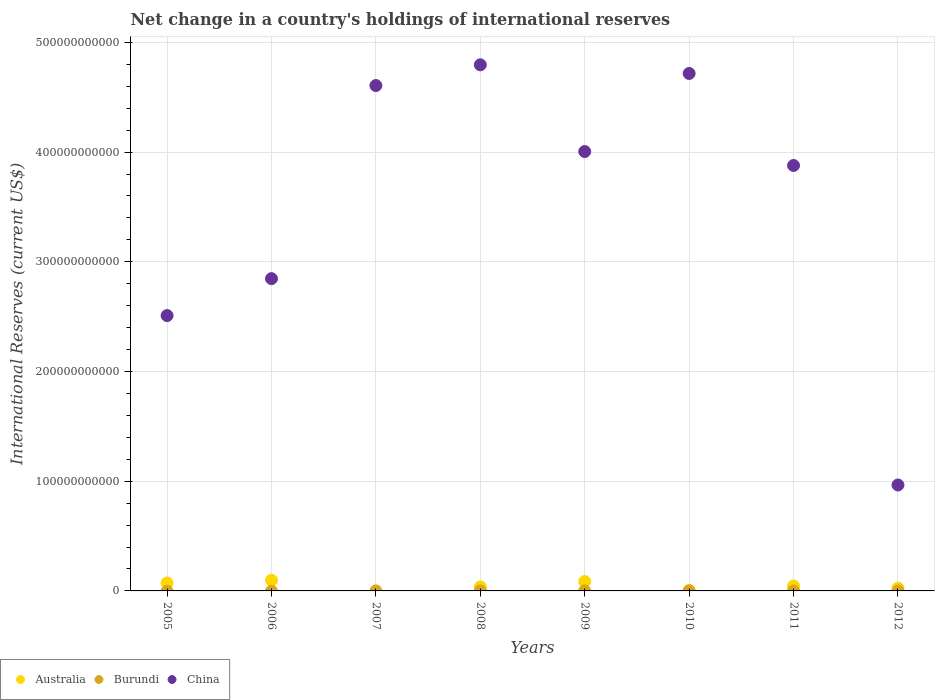How many different coloured dotlines are there?
Keep it short and to the point. 3. Across all years, what is the maximum international reserves in Australia?
Ensure brevity in your answer.  9.72e+09. Across all years, what is the minimum international reserves in Burundi?
Provide a short and direct response. 0. What is the total international reserves in Burundi in the graph?
Make the answer very short. 2.48e+08. What is the difference between the international reserves in Australia in 2006 and that in 2008?
Offer a terse response. 6.03e+09. What is the difference between the international reserves in Burundi in 2006 and the international reserves in China in 2009?
Keep it short and to the point. -4.01e+11. What is the average international reserves in China per year?
Offer a very short reply. 3.54e+11. In the year 2012, what is the difference between the international reserves in Burundi and international reserves in China?
Provide a succinct answer. -9.65e+1. What is the ratio of the international reserves in Australia in 2008 to that in 2009?
Give a very brief answer. 0.43. Is the international reserves in China in 2005 less than that in 2011?
Make the answer very short. Yes. What is the difference between the highest and the second highest international reserves in Australia?
Ensure brevity in your answer.  1.17e+09. What is the difference between the highest and the lowest international reserves in China?
Offer a terse response. 3.83e+11. In how many years, is the international reserves in Burundi greater than the average international reserves in Burundi taken over all years?
Offer a terse response. 3. Is it the case that in every year, the sum of the international reserves in Burundi and international reserves in China  is greater than the international reserves in Australia?
Offer a terse response. Yes. Is the international reserves in Burundi strictly greater than the international reserves in Australia over the years?
Offer a terse response. No. How many years are there in the graph?
Provide a succinct answer. 8. What is the difference between two consecutive major ticks on the Y-axis?
Your response must be concise. 1.00e+11. Are the values on the major ticks of Y-axis written in scientific E-notation?
Keep it short and to the point. No. Does the graph contain grids?
Offer a very short reply. Yes. How are the legend labels stacked?
Offer a terse response. Horizontal. What is the title of the graph?
Give a very brief answer. Net change in a country's holdings of international reserves. What is the label or title of the X-axis?
Provide a short and direct response. Years. What is the label or title of the Y-axis?
Ensure brevity in your answer.  International Reserves (current US$). What is the International Reserves (current US$) in Australia in 2005?
Make the answer very short. 7.25e+09. What is the International Reserves (current US$) in China in 2005?
Offer a terse response. 2.51e+11. What is the International Reserves (current US$) in Australia in 2006?
Provide a short and direct response. 9.72e+09. What is the International Reserves (current US$) in China in 2006?
Make the answer very short. 2.85e+11. What is the International Reserves (current US$) of Burundi in 2007?
Provide a short and direct response. 5.10e+07. What is the International Reserves (current US$) in China in 2007?
Ensure brevity in your answer.  4.61e+11. What is the International Reserves (current US$) of Australia in 2008?
Your answer should be very brief. 3.69e+09. What is the International Reserves (current US$) in Burundi in 2008?
Ensure brevity in your answer.  8.81e+07. What is the International Reserves (current US$) in China in 2008?
Your response must be concise. 4.80e+11. What is the International Reserves (current US$) of Australia in 2009?
Ensure brevity in your answer.  8.55e+09. What is the International Reserves (current US$) in Burundi in 2009?
Your answer should be very brief. 8.16e+07. What is the International Reserves (current US$) in China in 2009?
Offer a terse response. 4.01e+11. What is the International Reserves (current US$) in Australia in 2010?
Keep it short and to the point. 4.30e+08. What is the International Reserves (current US$) of China in 2010?
Your answer should be very brief. 4.72e+11. What is the International Reserves (current US$) in Australia in 2011?
Offer a terse response. 4.55e+09. What is the International Reserves (current US$) of Burundi in 2011?
Ensure brevity in your answer.  0. What is the International Reserves (current US$) of China in 2011?
Offer a terse response. 3.88e+11. What is the International Reserves (current US$) in Australia in 2012?
Offer a terse response. 2.54e+09. What is the International Reserves (current US$) in Burundi in 2012?
Your response must be concise. 2.76e+07. What is the International Reserves (current US$) of China in 2012?
Ensure brevity in your answer.  9.66e+1. Across all years, what is the maximum International Reserves (current US$) in Australia?
Offer a terse response. 9.72e+09. Across all years, what is the maximum International Reserves (current US$) of Burundi?
Offer a terse response. 8.81e+07. Across all years, what is the maximum International Reserves (current US$) in China?
Your answer should be very brief. 4.80e+11. Across all years, what is the minimum International Reserves (current US$) of Australia?
Ensure brevity in your answer.  0. Across all years, what is the minimum International Reserves (current US$) in Burundi?
Your answer should be compact. 0. Across all years, what is the minimum International Reserves (current US$) in China?
Give a very brief answer. 9.66e+1. What is the total International Reserves (current US$) in Australia in the graph?
Your answer should be very brief. 3.67e+1. What is the total International Reserves (current US$) of Burundi in the graph?
Give a very brief answer. 2.48e+08. What is the total International Reserves (current US$) of China in the graph?
Provide a succinct answer. 2.83e+12. What is the difference between the International Reserves (current US$) of Australia in 2005 and that in 2006?
Offer a terse response. -2.47e+09. What is the difference between the International Reserves (current US$) in China in 2005 and that in 2006?
Provide a succinct answer. -3.37e+1. What is the difference between the International Reserves (current US$) in China in 2005 and that in 2007?
Provide a succinct answer. -2.10e+11. What is the difference between the International Reserves (current US$) in Australia in 2005 and that in 2008?
Give a very brief answer. 3.56e+09. What is the difference between the International Reserves (current US$) in China in 2005 and that in 2008?
Offer a terse response. -2.29e+11. What is the difference between the International Reserves (current US$) of Australia in 2005 and that in 2009?
Make the answer very short. -1.29e+09. What is the difference between the International Reserves (current US$) in China in 2005 and that in 2009?
Give a very brief answer. -1.50e+11. What is the difference between the International Reserves (current US$) in Australia in 2005 and that in 2010?
Provide a succinct answer. 6.82e+09. What is the difference between the International Reserves (current US$) of China in 2005 and that in 2010?
Your response must be concise. -2.21e+11. What is the difference between the International Reserves (current US$) in Australia in 2005 and that in 2011?
Your response must be concise. 2.71e+09. What is the difference between the International Reserves (current US$) of China in 2005 and that in 2011?
Offer a very short reply. -1.37e+11. What is the difference between the International Reserves (current US$) in Australia in 2005 and that in 2012?
Provide a succinct answer. 4.72e+09. What is the difference between the International Reserves (current US$) in China in 2005 and that in 2012?
Provide a succinct answer. 1.54e+11. What is the difference between the International Reserves (current US$) of China in 2006 and that in 2007?
Your answer should be compact. -1.76e+11. What is the difference between the International Reserves (current US$) of Australia in 2006 and that in 2008?
Ensure brevity in your answer.  6.03e+09. What is the difference between the International Reserves (current US$) in China in 2006 and that in 2008?
Your answer should be compact. -1.95e+11. What is the difference between the International Reserves (current US$) of Australia in 2006 and that in 2009?
Offer a very short reply. 1.17e+09. What is the difference between the International Reserves (current US$) of China in 2006 and that in 2009?
Your answer should be very brief. -1.16e+11. What is the difference between the International Reserves (current US$) of Australia in 2006 and that in 2010?
Offer a terse response. 9.29e+09. What is the difference between the International Reserves (current US$) in China in 2006 and that in 2010?
Your answer should be compact. -1.87e+11. What is the difference between the International Reserves (current US$) in Australia in 2006 and that in 2011?
Your response must be concise. 5.18e+09. What is the difference between the International Reserves (current US$) of China in 2006 and that in 2011?
Your response must be concise. -1.03e+11. What is the difference between the International Reserves (current US$) in Australia in 2006 and that in 2012?
Ensure brevity in your answer.  7.19e+09. What is the difference between the International Reserves (current US$) in China in 2006 and that in 2012?
Ensure brevity in your answer.  1.88e+11. What is the difference between the International Reserves (current US$) of Burundi in 2007 and that in 2008?
Offer a terse response. -3.71e+07. What is the difference between the International Reserves (current US$) of China in 2007 and that in 2008?
Offer a terse response. -1.89e+1. What is the difference between the International Reserves (current US$) of Burundi in 2007 and that in 2009?
Offer a terse response. -3.06e+07. What is the difference between the International Reserves (current US$) of China in 2007 and that in 2009?
Your answer should be very brief. 6.01e+1. What is the difference between the International Reserves (current US$) of China in 2007 and that in 2010?
Your answer should be compact. -1.10e+1. What is the difference between the International Reserves (current US$) in China in 2007 and that in 2011?
Keep it short and to the point. 7.29e+1. What is the difference between the International Reserves (current US$) of Burundi in 2007 and that in 2012?
Your answer should be very brief. 2.33e+07. What is the difference between the International Reserves (current US$) in China in 2007 and that in 2012?
Your response must be concise. 3.64e+11. What is the difference between the International Reserves (current US$) of Australia in 2008 and that in 2009?
Make the answer very short. -4.86e+09. What is the difference between the International Reserves (current US$) of Burundi in 2008 and that in 2009?
Ensure brevity in your answer.  6.47e+06. What is the difference between the International Reserves (current US$) of China in 2008 and that in 2009?
Keep it short and to the point. 7.90e+1. What is the difference between the International Reserves (current US$) of Australia in 2008 and that in 2010?
Give a very brief answer. 3.26e+09. What is the difference between the International Reserves (current US$) of China in 2008 and that in 2010?
Offer a very short reply. 7.89e+09. What is the difference between the International Reserves (current US$) of Australia in 2008 and that in 2011?
Ensure brevity in your answer.  -8.55e+08. What is the difference between the International Reserves (current US$) in China in 2008 and that in 2011?
Your answer should be very brief. 9.18e+1. What is the difference between the International Reserves (current US$) of Australia in 2008 and that in 2012?
Offer a terse response. 1.16e+09. What is the difference between the International Reserves (current US$) of Burundi in 2008 and that in 2012?
Keep it short and to the point. 6.04e+07. What is the difference between the International Reserves (current US$) in China in 2008 and that in 2012?
Your answer should be compact. 3.83e+11. What is the difference between the International Reserves (current US$) in Australia in 2009 and that in 2010?
Your response must be concise. 8.12e+09. What is the difference between the International Reserves (current US$) of China in 2009 and that in 2010?
Ensure brevity in your answer.  -7.12e+1. What is the difference between the International Reserves (current US$) in Australia in 2009 and that in 2011?
Offer a very short reply. 4.00e+09. What is the difference between the International Reserves (current US$) of China in 2009 and that in 2011?
Keep it short and to the point. 1.27e+1. What is the difference between the International Reserves (current US$) of Australia in 2009 and that in 2012?
Your answer should be very brief. 6.01e+09. What is the difference between the International Reserves (current US$) of Burundi in 2009 and that in 2012?
Provide a short and direct response. 5.39e+07. What is the difference between the International Reserves (current US$) in China in 2009 and that in 2012?
Make the answer very short. 3.04e+11. What is the difference between the International Reserves (current US$) in Australia in 2010 and that in 2011?
Offer a terse response. -4.12e+09. What is the difference between the International Reserves (current US$) in China in 2010 and that in 2011?
Provide a succinct answer. 8.39e+1. What is the difference between the International Reserves (current US$) of Australia in 2010 and that in 2012?
Your response must be concise. -2.11e+09. What is the difference between the International Reserves (current US$) in China in 2010 and that in 2012?
Provide a short and direct response. 3.75e+11. What is the difference between the International Reserves (current US$) in Australia in 2011 and that in 2012?
Provide a succinct answer. 2.01e+09. What is the difference between the International Reserves (current US$) in China in 2011 and that in 2012?
Keep it short and to the point. 2.91e+11. What is the difference between the International Reserves (current US$) in Australia in 2005 and the International Reserves (current US$) in China in 2006?
Make the answer very short. -2.77e+11. What is the difference between the International Reserves (current US$) in Australia in 2005 and the International Reserves (current US$) in Burundi in 2007?
Give a very brief answer. 7.20e+09. What is the difference between the International Reserves (current US$) of Australia in 2005 and the International Reserves (current US$) of China in 2007?
Keep it short and to the point. -4.53e+11. What is the difference between the International Reserves (current US$) in Australia in 2005 and the International Reserves (current US$) in Burundi in 2008?
Keep it short and to the point. 7.17e+09. What is the difference between the International Reserves (current US$) of Australia in 2005 and the International Reserves (current US$) of China in 2008?
Your answer should be compact. -4.72e+11. What is the difference between the International Reserves (current US$) of Australia in 2005 and the International Reserves (current US$) of Burundi in 2009?
Provide a short and direct response. 7.17e+09. What is the difference between the International Reserves (current US$) in Australia in 2005 and the International Reserves (current US$) in China in 2009?
Offer a very short reply. -3.93e+11. What is the difference between the International Reserves (current US$) of Australia in 2005 and the International Reserves (current US$) of China in 2010?
Keep it short and to the point. -4.64e+11. What is the difference between the International Reserves (current US$) of Australia in 2005 and the International Reserves (current US$) of China in 2011?
Offer a very short reply. -3.81e+11. What is the difference between the International Reserves (current US$) in Australia in 2005 and the International Reserves (current US$) in Burundi in 2012?
Your answer should be very brief. 7.23e+09. What is the difference between the International Reserves (current US$) in Australia in 2005 and the International Reserves (current US$) in China in 2012?
Your response must be concise. -8.93e+1. What is the difference between the International Reserves (current US$) in Australia in 2006 and the International Reserves (current US$) in Burundi in 2007?
Provide a short and direct response. 9.67e+09. What is the difference between the International Reserves (current US$) in Australia in 2006 and the International Reserves (current US$) in China in 2007?
Make the answer very short. -4.51e+11. What is the difference between the International Reserves (current US$) in Australia in 2006 and the International Reserves (current US$) in Burundi in 2008?
Ensure brevity in your answer.  9.63e+09. What is the difference between the International Reserves (current US$) of Australia in 2006 and the International Reserves (current US$) of China in 2008?
Your answer should be very brief. -4.70e+11. What is the difference between the International Reserves (current US$) of Australia in 2006 and the International Reserves (current US$) of Burundi in 2009?
Your answer should be compact. 9.64e+09. What is the difference between the International Reserves (current US$) of Australia in 2006 and the International Reserves (current US$) of China in 2009?
Provide a short and direct response. -3.91e+11. What is the difference between the International Reserves (current US$) of Australia in 2006 and the International Reserves (current US$) of China in 2010?
Your answer should be compact. -4.62e+11. What is the difference between the International Reserves (current US$) in Australia in 2006 and the International Reserves (current US$) in China in 2011?
Give a very brief answer. -3.78e+11. What is the difference between the International Reserves (current US$) in Australia in 2006 and the International Reserves (current US$) in Burundi in 2012?
Offer a terse response. 9.70e+09. What is the difference between the International Reserves (current US$) in Australia in 2006 and the International Reserves (current US$) in China in 2012?
Keep it short and to the point. -8.68e+1. What is the difference between the International Reserves (current US$) of Burundi in 2007 and the International Reserves (current US$) of China in 2008?
Your answer should be very brief. -4.80e+11. What is the difference between the International Reserves (current US$) in Burundi in 2007 and the International Reserves (current US$) in China in 2009?
Ensure brevity in your answer.  -4.00e+11. What is the difference between the International Reserves (current US$) in Burundi in 2007 and the International Reserves (current US$) in China in 2010?
Offer a very short reply. -4.72e+11. What is the difference between the International Reserves (current US$) in Burundi in 2007 and the International Reserves (current US$) in China in 2011?
Your answer should be compact. -3.88e+11. What is the difference between the International Reserves (current US$) in Burundi in 2007 and the International Reserves (current US$) in China in 2012?
Your answer should be compact. -9.65e+1. What is the difference between the International Reserves (current US$) in Australia in 2008 and the International Reserves (current US$) in Burundi in 2009?
Offer a terse response. 3.61e+09. What is the difference between the International Reserves (current US$) of Australia in 2008 and the International Reserves (current US$) of China in 2009?
Provide a succinct answer. -3.97e+11. What is the difference between the International Reserves (current US$) in Burundi in 2008 and the International Reserves (current US$) in China in 2009?
Keep it short and to the point. -4.00e+11. What is the difference between the International Reserves (current US$) in Australia in 2008 and the International Reserves (current US$) in China in 2010?
Provide a short and direct response. -4.68e+11. What is the difference between the International Reserves (current US$) of Burundi in 2008 and the International Reserves (current US$) of China in 2010?
Provide a short and direct response. -4.72e+11. What is the difference between the International Reserves (current US$) of Australia in 2008 and the International Reserves (current US$) of China in 2011?
Provide a short and direct response. -3.84e+11. What is the difference between the International Reserves (current US$) in Burundi in 2008 and the International Reserves (current US$) in China in 2011?
Make the answer very short. -3.88e+11. What is the difference between the International Reserves (current US$) in Australia in 2008 and the International Reserves (current US$) in Burundi in 2012?
Make the answer very short. 3.66e+09. What is the difference between the International Reserves (current US$) of Australia in 2008 and the International Reserves (current US$) of China in 2012?
Ensure brevity in your answer.  -9.29e+1. What is the difference between the International Reserves (current US$) in Burundi in 2008 and the International Reserves (current US$) in China in 2012?
Offer a very short reply. -9.65e+1. What is the difference between the International Reserves (current US$) of Australia in 2009 and the International Reserves (current US$) of China in 2010?
Your response must be concise. -4.63e+11. What is the difference between the International Reserves (current US$) in Burundi in 2009 and the International Reserves (current US$) in China in 2010?
Provide a succinct answer. -4.72e+11. What is the difference between the International Reserves (current US$) in Australia in 2009 and the International Reserves (current US$) in China in 2011?
Give a very brief answer. -3.79e+11. What is the difference between the International Reserves (current US$) of Burundi in 2009 and the International Reserves (current US$) of China in 2011?
Provide a short and direct response. -3.88e+11. What is the difference between the International Reserves (current US$) in Australia in 2009 and the International Reserves (current US$) in Burundi in 2012?
Give a very brief answer. 8.52e+09. What is the difference between the International Reserves (current US$) of Australia in 2009 and the International Reserves (current US$) of China in 2012?
Offer a very short reply. -8.80e+1. What is the difference between the International Reserves (current US$) in Burundi in 2009 and the International Reserves (current US$) in China in 2012?
Offer a very short reply. -9.65e+1. What is the difference between the International Reserves (current US$) in Australia in 2010 and the International Reserves (current US$) in China in 2011?
Keep it short and to the point. -3.87e+11. What is the difference between the International Reserves (current US$) in Australia in 2010 and the International Reserves (current US$) in Burundi in 2012?
Keep it short and to the point. 4.02e+08. What is the difference between the International Reserves (current US$) in Australia in 2010 and the International Reserves (current US$) in China in 2012?
Give a very brief answer. -9.61e+1. What is the difference between the International Reserves (current US$) of Australia in 2011 and the International Reserves (current US$) of Burundi in 2012?
Offer a very short reply. 4.52e+09. What is the difference between the International Reserves (current US$) of Australia in 2011 and the International Reserves (current US$) of China in 2012?
Offer a very short reply. -9.20e+1. What is the average International Reserves (current US$) of Australia per year?
Make the answer very short. 4.59e+09. What is the average International Reserves (current US$) of Burundi per year?
Your answer should be very brief. 3.10e+07. What is the average International Reserves (current US$) of China per year?
Make the answer very short. 3.54e+11. In the year 2005, what is the difference between the International Reserves (current US$) of Australia and International Reserves (current US$) of China?
Your answer should be compact. -2.44e+11. In the year 2006, what is the difference between the International Reserves (current US$) of Australia and International Reserves (current US$) of China?
Give a very brief answer. -2.75e+11. In the year 2007, what is the difference between the International Reserves (current US$) in Burundi and International Reserves (current US$) in China?
Offer a terse response. -4.61e+11. In the year 2008, what is the difference between the International Reserves (current US$) of Australia and International Reserves (current US$) of Burundi?
Your answer should be compact. 3.60e+09. In the year 2008, what is the difference between the International Reserves (current US$) in Australia and International Reserves (current US$) in China?
Your response must be concise. -4.76e+11. In the year 2008, what is the difference between the International Reserves (current US$) of Burundi and International Reserves (current US$) of China?
Offer a very short reply. -4.79e+11. In the year 2009, what is the difference between the International Reserves (current US$) in Australia and International Reserves (current US$) in Burundi?
Your response must be concise. 8.47e+09. In the year 2009, what is the difference between the International Reserves (current US$) in Australia and International Reserves (current US$) in China?
Offer a terse response. -3.92e+11. In the year 2009, what is the difference between the International Reserves (current US$) of Burundi and International Reserves (current US$) of China?
Provide a short and direct response. -4.00e+11. In the year 2010, what is the difference between the International Reserves (current US$) of Australia and International Reserves (current US$) of China?
Your answer should be compact. -4.71e+11. In the year 2011, what is the difference between the International Reserves (current US$) in Australia and International Reserves (current US$) in China?
Keep it short and to the point. -3.83e+11. In the year 2012, what is the difference between the International Reserves (current US$) in Australia and International Reserves (current US$) in Burundi?
Offer a very short reply. 2.51e+09. In the year 2012, what is the difference between the International Reserves (current US$) in Australia and International Reserves (current US$) in China?
Keep it short and to the point. -9.40e+1. In the year 2012, what is the difference between the International Reserves (current US$) of Burundi and International Reserves (current US$) of China?
Offer a terse response. -9.65e+1. What is the ratio of the International Reserves (current US$) of Australia in 2005 to that in 2006?
Keep it short and to the point. 0.75. What is the ratio of the International Reserves (current US$) of China in 2005 to that in 2006?
Give a very brief answer. 0.88. What is the ratio of the International Reserves (current US$) in China in 2005 to that in 2007?
Your answer should be very brief. 0.54. What is the ratio of the International Reserves (current US$) of Australia in 2005 to that in 2008?
Make the answer very short. 1.97. What is the ratio of the International Reserves (current US$) of China in 2005 to that in 2008?
Your answer should be compact. 0.52. What is the ratio of the International Reserves (current US$) of Australia in 2005 to that in 2009?
Offer a terse response. 0.85. What is the ratio of the International Reserves (current US$) in China in 2005 to that in 2009?
Make the answer very short. 0.63. What is the ratio of the International Reserves (current US$) in Australia in 2005 to that in 2010?
Offer a very short reply. 16.87. What is the ratio of the International Reserves (current US$) in China in 2005 to that in 2010?
Offer a very short reply. 0.53. What is the ratio of the International Reserves (current US$) in Australia in 2005 to that in 2011?
Offer a terse response. 1.6. What is the ratio of the International Reserves (current US$) of China in 2005 to that in 2011?
Provide a short and direct response. 0.65. What is the ratio of the International Reserves (current US$) in Australia in 2005 to that in 2012?
Keep it short and to the point. 2.86. What is the ratio of the International Reserves (current US$) in China in 2005 to that in 2012?
Keep it short and to the point. 2.6. What is the ratio of the International Reserves (current US$) in China in 2006 to that in 2007?
Your answer should be very brief. 0.62. What is the ratio of the International Reserves (current US$) in Australia in 2006 to that in 2008?
Make the answer very short. 2.63. What is the ratio of the International Reserves (current US$) in China in 2006 to that in 2008?
Offer a terse response. 0.59. What is the ratio of the International Reserves (current US$) of Australia in 2006 to that in 2009?
Give a very brief answer. 1.14. What is the ratio of the International Reserves (current US$) of China in 2006 to that in 2009?
Offer a terse response. 0.71. What is the ratio of the International Reserves (current US$) of Australia in 2006 to that in 2010?
Your answer should be very brief. 22.61. What is the ratio of the International Reserves (current US$) of China in 2006 to that in 2010?
Your response must be concise. 0.6. What is the ratio of the International Reserves (current US$) in Australia in 2006 to that in 2011?
Offer a very short reply. 2.14. What is the ratio of the International Reserves (current US$) of China in 2006 to that in 2011?
Offer a very short reply. 0.73. What is the ratio of the International Reserves (current US$) of Australia in 2006 to that in 2012?
Keep it short and to the point. 3.83. What is the ratio of the International Reserves (current US$) in China in 2006 to that in 2012?
Your response must be concise. 2.95. What is the ratio of the International Reserves (current US$) of Burundi in 2007 to that in 2008?
Provide a short and direct response. 0.58. What is the ratio of the International Reserves (current US$) of China in 2007 to that in 2008?
Make the answer very short. 0.96. What is the ratio of the International Reserves (current US$) in Burundi in 2007 to that in 2009?
Provide a short and direct response. 0.62. What is the ratio of the International Reserves (current US$) of China in 2007 to that in 2009?
Your answer should be compact. 1.15. What is the ratio of the International Reserves (current US$) in China in 2007 to that in 2010?
Your answer should be very brief. 0.98. What is the ratio of the International Reserves (current US$) of China in 2007 to that in 2011?
Ensure brevity in your answer.  1.19. What is the ratio of the International Reserves (current US$) in Burundi in 2007 to that in 2012?
Your response must be concise. 1.84. What is the ratio of the International Reserves (current US$) of China in 2007 to that in 2012?
Ensure brevity in your answer.  4.77. What is the ratio of the International Reserves (current US$) in Australia in 2008 to that in 2009?
Give a very brief answer. 0.43. What is the ratio of the International Reserves (current US$) in Burundi in 2008 to that in 2009?
Offer a terse response. 1.08. What is the ratio of the International Reserves (current US$) in China in 2008 to that in 2009?
Offer a terse response. 1.2. What is the ratio of the International Reserves (current US$) in Australia in 2008 to that in 2010?
Ensure brevity in your answer.  8.59. What is the ratio of the International Reserves (current US$) of China in 2008 to that in 2010?
Your answer should be very brief. 1.02. What is the ratio of the International Reserves (current US$) in Australia in 2008 to that in 2011?
Provide a succinct answer. 0.81. What is the ratio of the International Reserves (current US$) in China in 2008 to that in 2011?
Your answer should be compact. 1.24. What is the ratio of the International Reserves (current US$) of Australia in 2008 to that in 2012?
Provide a succinct answer. 1.46. What is the ratio of the International Reserves (current US$) in Burundi in 2008 to that in 2012?
Your response must be concise. 3.19. What is the ratio of the International Reserves (current US$) of China in 2008 to that in 2012?
Keep it short and to the point. 4.97. What is the ratio of the International Reserves (current US$) of Australia in 2009 to that in 2010?
Your response must be concise. 19.88. What is the ratio of the International Reserves (current US$) of China in 2009 to that in 2010?
Make the answer very short. 0.85. What is the ratio of the International Reserves (current US$) in Australia in 2009 to that in 2011?
Provide a succinct answer. 1.88. What is the ratio of the International Reserves (current US$) of China in 2009 to that in 2011?
Your answer should be compact. 1.03. What is the ratio of the International Reserves (current US$) in Australia in 2009 to that in 2012?
Offer a terse response. 3.37. What is the ratio of the International Reserves (current US$) in Burundi in 2009 to that in 2012?
Provide a succinct answer. 2.95. What is the ratio of the International Reserves (current US$) in China in 2009 to that in 2012?
Your response must be concise. 4.15. What is the ratio of the International Reserves (current US$) in Australia in 2010 to that in 2011?
Make the answer very short. 0.09. What is the ratio of the International Reserves (current US$) of China in 2010 to that in 2011?
Ensure brevity in your answer.  1.22. What is the ratio of the International Reserves (current US$) in Australia in 2010 to that in 2012?
Your response must be concise. 0.17. What is the ratio of the International Reserves (current US$) in China in 2010 to that in 2012?
Keep it short and to the point. 4.88. What is the ratio of the International Reserves (current US$) of Australia in 2011 to that in 2012?
Your answer should be compact. 1.79. What is the ratio of the International Reserves (current US$) in China in 2011 to that in 2012?
Your answer should be compact. 4.02. What is the difference between the highest and the second highest International Reserves (current US$) of Australia?
Your response must be concise. 1.17e+09. What is the difference between the highest and the second highest International Reserves (current US$) of Burundi?
Your answer should be compact. 6.47e+06. What is the difference between the highest and the second highest International Reserves (current US$) of China?
Keep it short and to the point. 7.89e+09. What is the difference between the highest and the lowest International Reserves (current US$) of Australia?
Your response must be concise. 9.72e+09. What is the difference between the highest and the lowest International Reserves (current US$) of Burundi?
Keep it short and to the point. 8.81e+07. What is the difference between the highest and the lowest International Reserves (current US$) in China?
Your answer should be compact. 3.83e+11. 